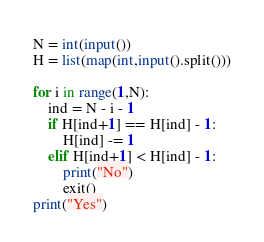<code> <loc_0><loc_0><loc_500><loc_500><_Python_>N = int(input())
H = list(map(int,input().split()))

for i in range(1,N):
    ind = N - i - 1
    if H[ind+1] == H[ind] - 1:
        H[ind] -= 1
    elif H[ind+1] < H[ind] - 1:
        print("No")
        exit()
print("Yes")
</code> 